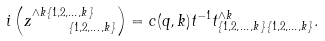Convert formula to latex. <formula><loc_0><loc_0><loc_500><loc_500>i \left ( z _ { \quad \{ 1 , 2 , \dots , k \} } ^ { \wedge k \{ 1 , 2 , \dots , k \} } \right ) = c ( q , k ) t ^ { - 1 } t _ { \{ 1 , 2 , \dots , k \} \{ 1 , 2 , \dots , k \} } ^ { \wedge k } .</formula> 